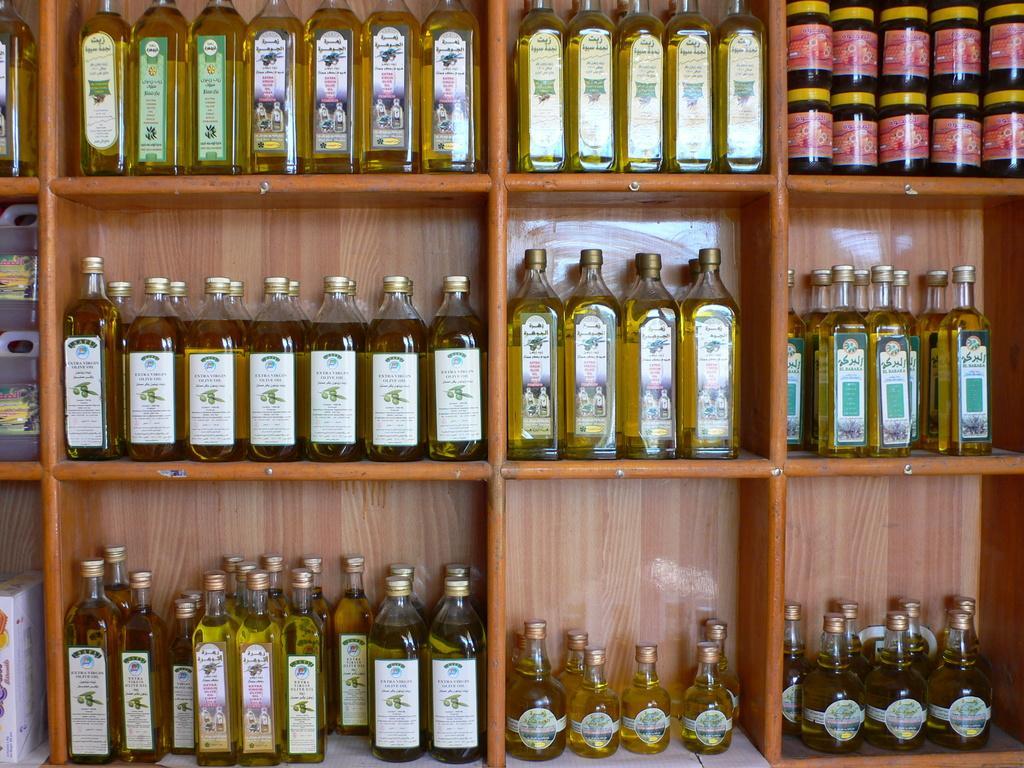Can you describe this image briefly? In this picture we can see a shelf in which there are some racks in which some bottles are places of different shapes and sizes. 